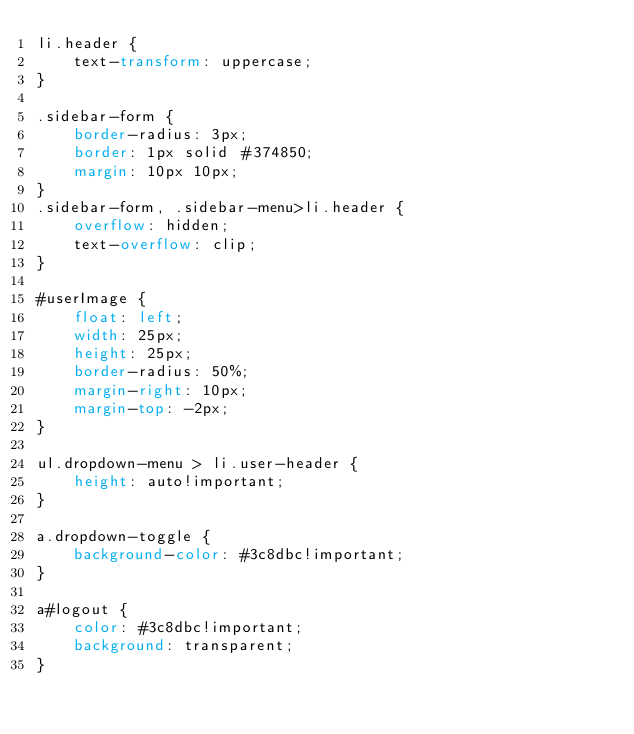Convert code to text. <code><loc_0><loc_0><loc_500><loc_500><_CSS_>li.header {
    text-transform: uppercase;
}

.sidebar-form {
    border-radius: 3px;
    border: 1px solid #374850;
    margin: 10px 10px;
}
.sidebar-form, .sidebar-menu>li.header {
    overflow: hidden;
    text-overflow: clip;
}

#userImage {
    float: left;
    width: 25px;
    height: 25px;
    border-radius: 50%;
    margin-right: 10px;
    margin-top: -2px;
}

ul.dropdown-menu > li.user-header {
    height: auto!important;
}

a.dropdown-toggle {
    background-color: #3c8dbc!important;
}

a#logout {
    color: #3c8dbc!important;
    background: transparent;
}</code> 